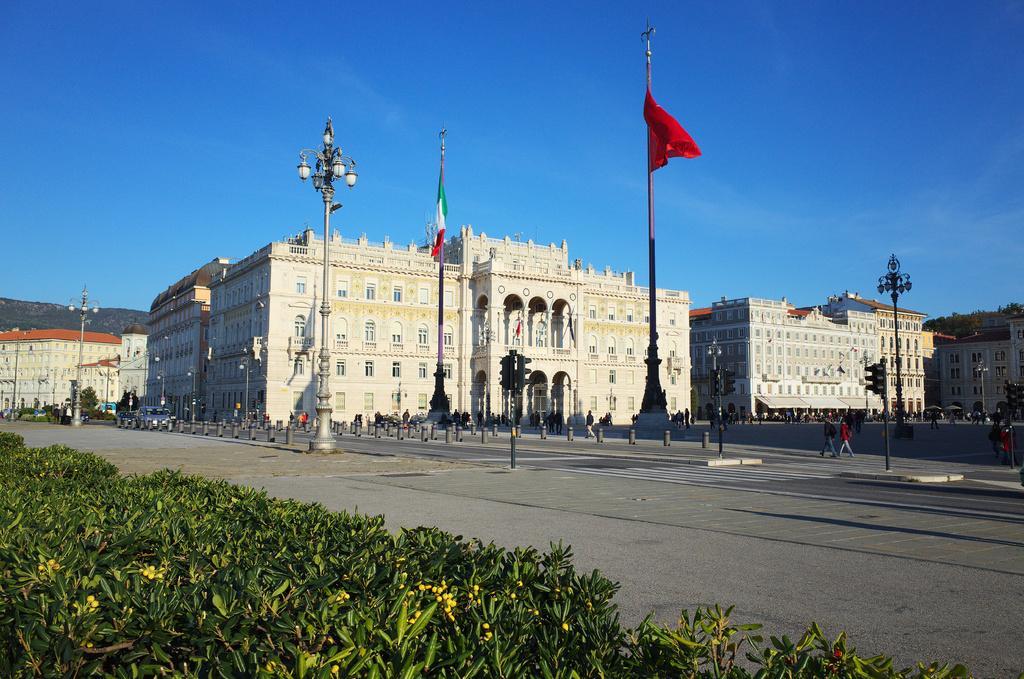Describe this image in one or two sentences. In the center of the image we can see the buildings, flagpoles, lights and some persons are there. At the bottom of the image some bushes are there. At the top of the image sky is there. In the middle of the image we can see mountains, roads, traffic lights are present. 